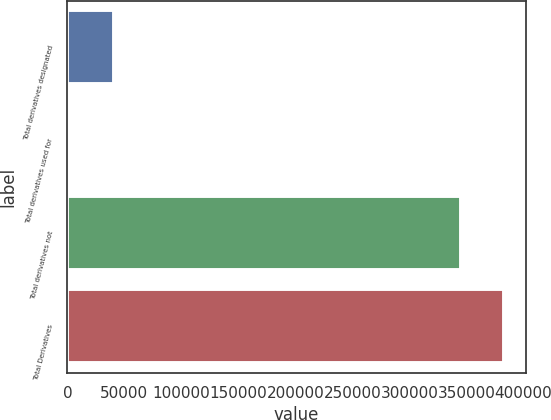<chart> <loc_0><loc_0><loc_500><loc_500><bar_chart><fcel>Total derivatives designated<fcel>Total derivatives used for<fcel>Total derivatives not<fcel>Total Derivatives<nl><fcel>40552.9<fcel>2697<fcel>345059<fcel>382915<nl></chart> 